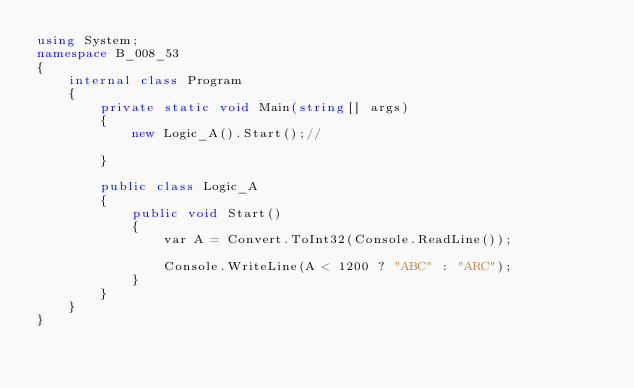Convert code to text. <code><loc_0><loc_0><loc_500><loc_500><_C#_>using System;
namespace B_008_53
{
    internal class Program
    {
        private static void Main(string[] args)
        {
            new Logic_A().Start();//
      
        }

        public class Logic_A
        {
            public void Start()
            {
                var A = Convert.ToInt32(Console.ReadLine());

                Console.WriteLine(A < 1200 ? "ABC" : "ARC");
            }
        }
    }
}</code> 